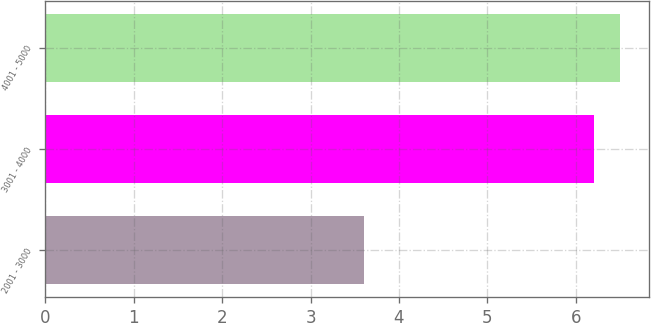<chart> <loc_0><loc_0><loc_500><loc_500><bar_chart><fcel>2001 - 3000<fcel>3001 - 4000<fcel>4001 - 5000<nl><fcel>3.6<fcel>6.2<fcel>6.5<nl></chart> 